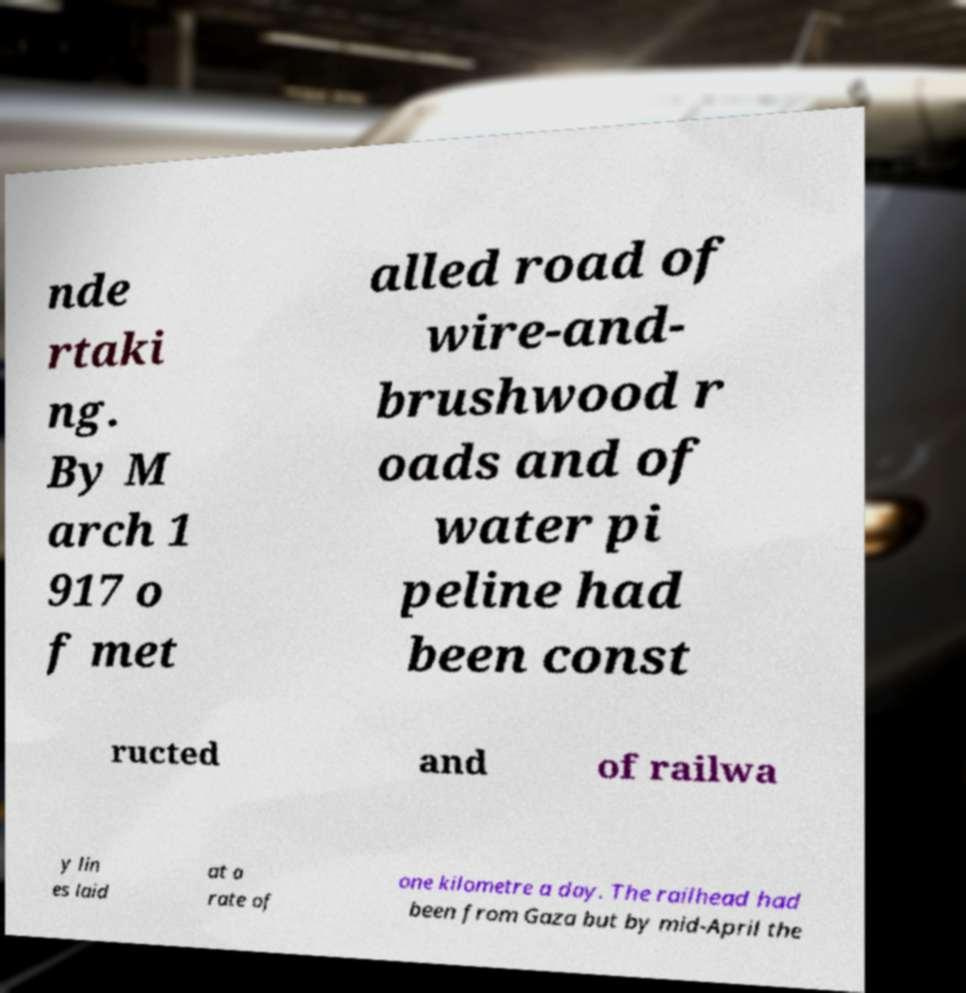Could you extract and type out the text from this image? nde rtaki ng. By M arch 1 917 o f met alled road of wire-and- brushwood r oads and of water pi peline had been const ructed and of railwa y lin es laid at a rate of one kilometre a day. The railhead had been from Gaza but by mid-April the 